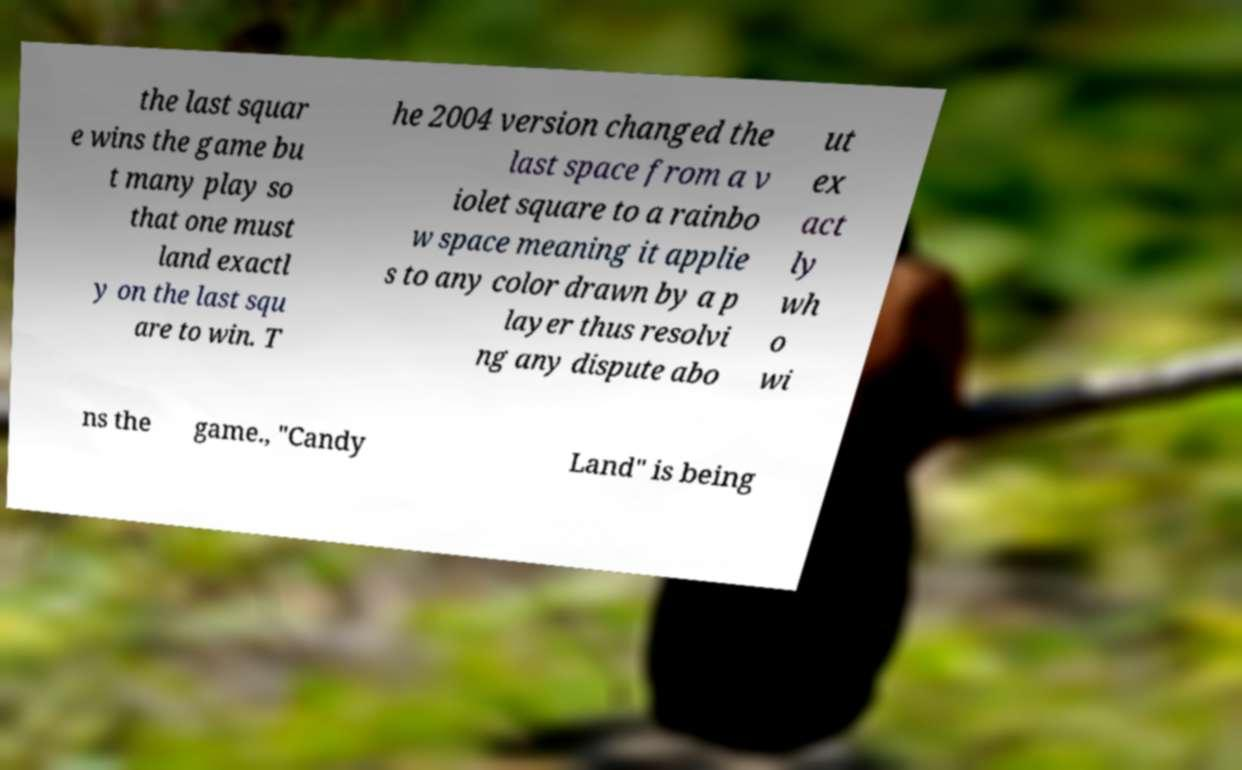Please identify and transcribe the text found in this image. the last squar e wins the game bu t many play so that one must land exactl y on the last squ are to win. T he 2004 version changed the last space from a v iolet square to a rainbo w space meaning it applie s to any color drawn by a p layer thus resolvi ng any dispute abo ut ex act ly wh o wi ns the game., "Candy Land" is being 